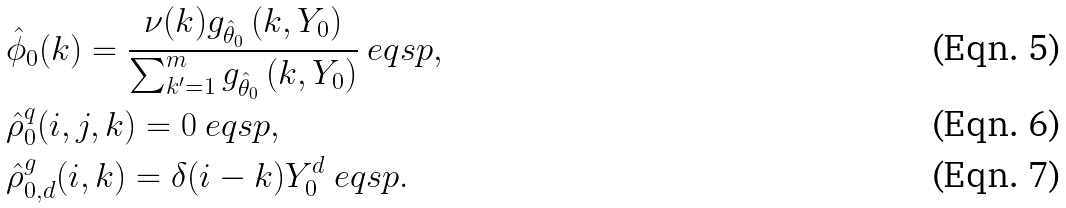Convert formula to latex. <formula><loc_0><loc_0><loc_500><loc_500>& \hat { \phi } _ { 0 } ( k ) = \frac { \nu ( k ) g _ { \hat { \theta } _ { 0 } } \, ( k , Y _ { 0 } ) } { \sum _ { k ^ { \prime } = 1 } ^ { m } g _ { \hat { \theta } _ { 0 } } \, ( k , Y _ { 0 } ) } \ e q s p , \\ & \hat { \rho } ^ { q } _ { 0 } ( i , j , k ) = 0 \ e q s p , \\ & \hat { \rho } ^ { g } _ { 0 , d } ( i , k ) = \delta ( i - k ) Y _ { 0 } ^ { d } \ e q s p .</formula> 